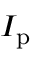<formula> <loc_0><loc_0><loc_500><loc_500>I _ { p }</formula> 